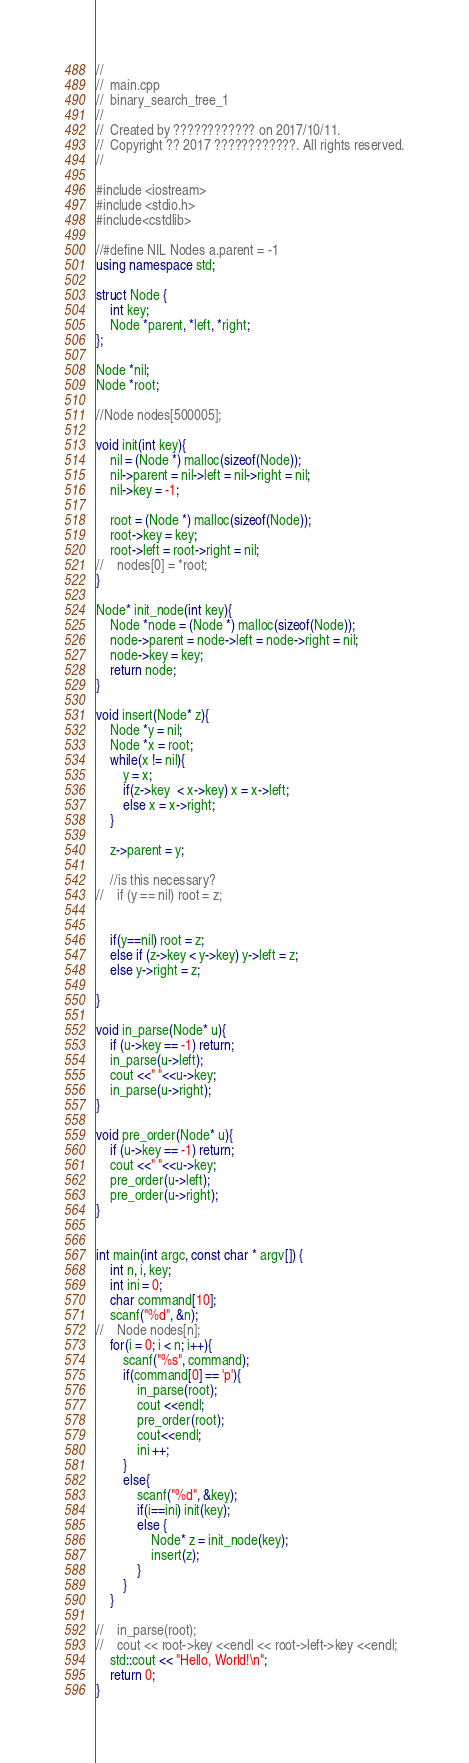Convert code to text. <code><loc_0><loc_0><loc_500><loc_500><_C++_>//
//  main.cpp
//  binary_search_tree_1
//
//  Created by ???????????? on 2017/10/11.
//  Copyright ?? 2017 ????????????. All rights reserved.
//

#include <iostream>
#include <stdio.h>
#include<cstdlib>

//#define NIL Nodes a.parent = -1
using namespace std;

struct Node {
    int key;
    Node *parent, *left, *right;
};

Node *nil;
Node *root;

//Node nodes[500005];

void init(int key){
    nil = (Node *) malloc(sizeof(Node));
    nil->parent = nil->left = nil->right = nil;
    nil->key = -1;
    
    root = (Node *) malloc(sizeof(Node));
    root->key = key;
    root->left = root->right = nil;
//    nodes[0] = *root;
}

Node* init_node(int key){
    Node *node = (Node *) malloc(sizeof(Node));
    node->parent = node->left = node->right = nil;
    node->key = key;
    return node;
}

void insert(Node* z){
    Node *y = nil;
    Node *x = root;
    while(x != nil){
        y = x;
        if(z->key  < x->key) x = x->left;
        else x = x->right;
    }
    
    z->parent = y;
    
    //is this necessary?
//    if (y == nil) root = z;
    
    
    if(y==nil) root = z;
    else if (z->key < y->key) y->left = z;
    else y->right = z;
    
}

void in_parse(Node* u){
    if (u->key == -1) return;
    in_parse(u->left);
    cout <<" "<<u->key;
    in_parse(u->right);
}

void pre_order(Node* u){
    if (u->key == -1) return;
    cout <<" "<<u->key;
    pre_order(u->left);
    pre_order(u->right);
}


int main(int argc, const char * argv[]) {
    int n, i, key;
    int ini = 0;
    char command[10];
    scanf("%d", &n);
//    Node nodes[n];
    for(i = 0; i < n; i++){
        scanf("%s", command);
        if(command[0] == 'p'){
            in_parse(root);
            cout <<endl;
            pre_order(root);
            cout<<endl;
            ini ++;
        }
        else{
            scanf("%d", &key);
            if(i==ini) init(key);
            else {
                Node* z = init_node(key);
                insert(z);
            }
        }
    }
    
//    in_parse(root);
//    cout << root->key <<endl << root->left->key <<endl;
    std::cout << "Hello, World!\n";
    return 0;
}</code> 